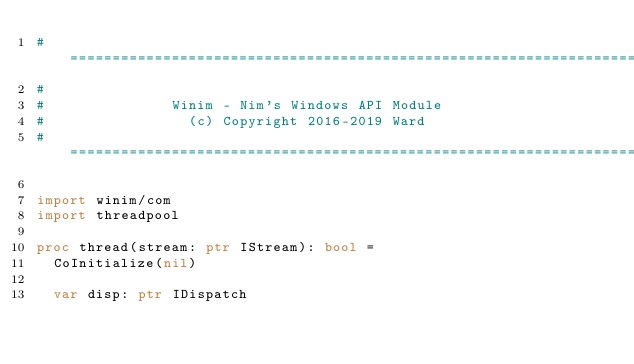Convert code to text. <code><loc_0><loc_0><loc_500><loc_500><_Nim_>#====================================================================
#
#               Winim - Nim's Windows API Module
#                 (c) Copyright 2016-2019 Ward
#====================================================================

import winim/com
import threadpool

proc thread(stream: ptr IStream): bool =
  CoInitialize(nil)

  var disp: ptr IDispatch</code> 